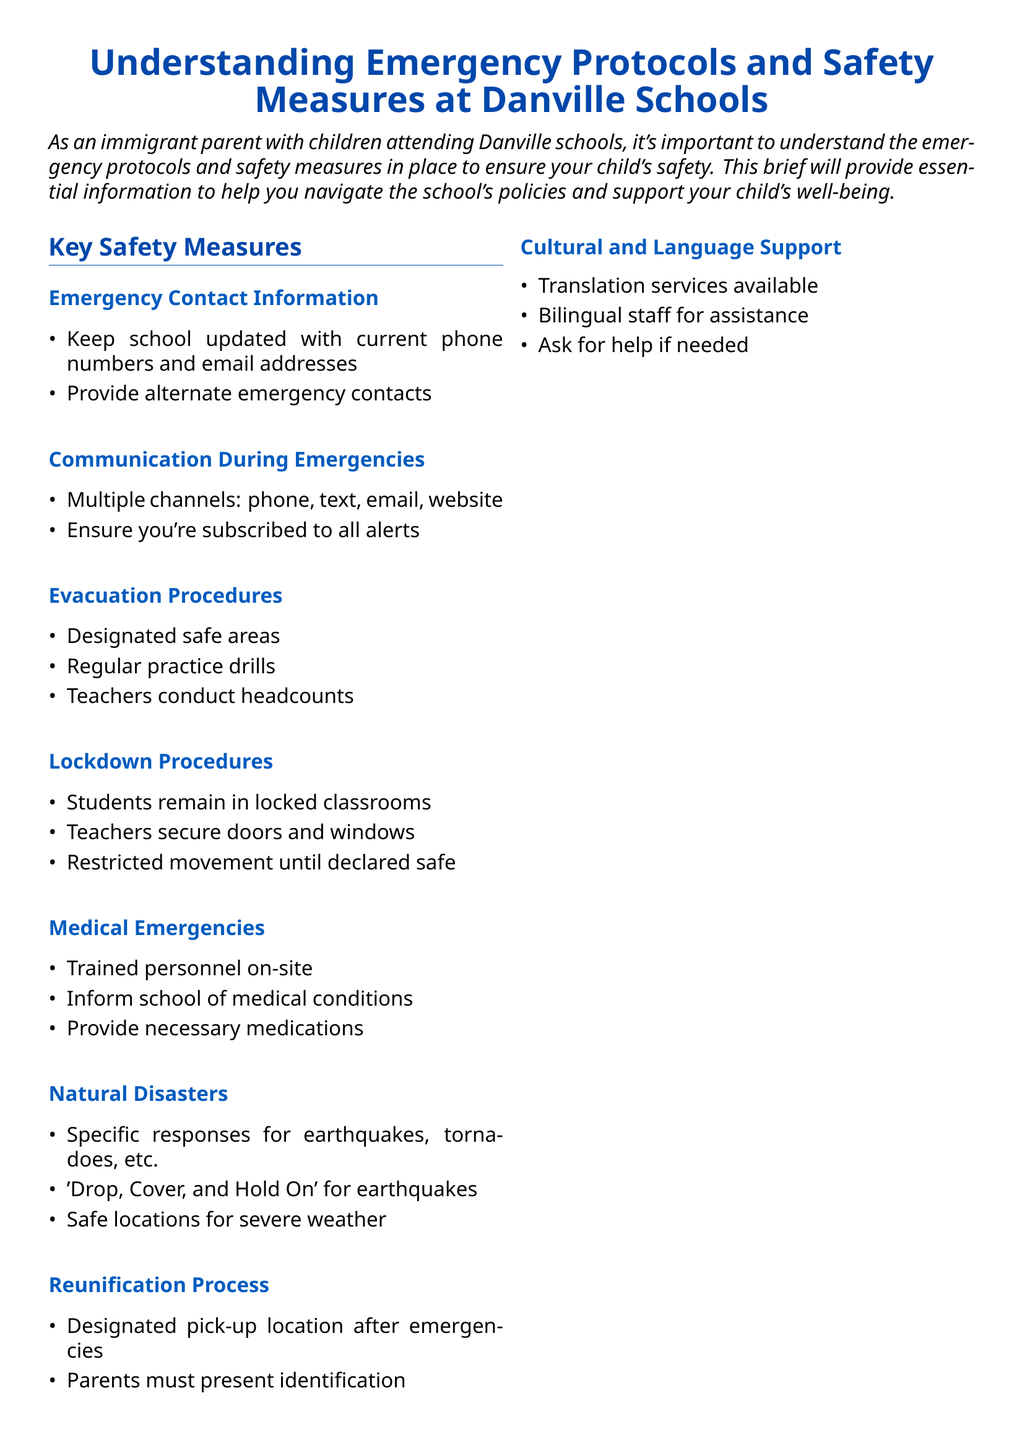What information should you keep updated with the school? The document states to keep the school updated with current phone numbers and email addresses along with providing alternate emergency contacts.
Answer: current phone numbers and email addresses What is one method for communication during emergencies? The document lists multiple channels for communication, including phone, text, email, and website.
Answer: phone What do teachers conduct during evacuation procedures? The document specifies that teachers conduct headcounts during evacuation procedures.
Answer: headcounts What should you provide the school regarding medical emergencies? The document advises informing the school of medical conditions and providing necessary medications.
Answer: medical conditions What is a specific response for earthquakes mentioned in the document? The document instructs to 'Drop, Cover, and Hold On' during earthquakes.
Answer: Drop, Cover, and Hold On What must parents present during the reunification process? According to the document, parents must present identification at the designated pick-up location after emergencies.
Answer: identification What support is available for language assistance? The document states that translation services and bilingual staff are available for assistance.
Answer: translation services How should parents engage regarding school safety? The document emphasizes that parents should attend school safety meetings when possible.
Answer: attend school safety meetings What is the school emergency number format mentioned? The document specifies the format as (XXX) XXX-XXXX for the school emergency number.
Answer: (XXX) XXX-XXXX 